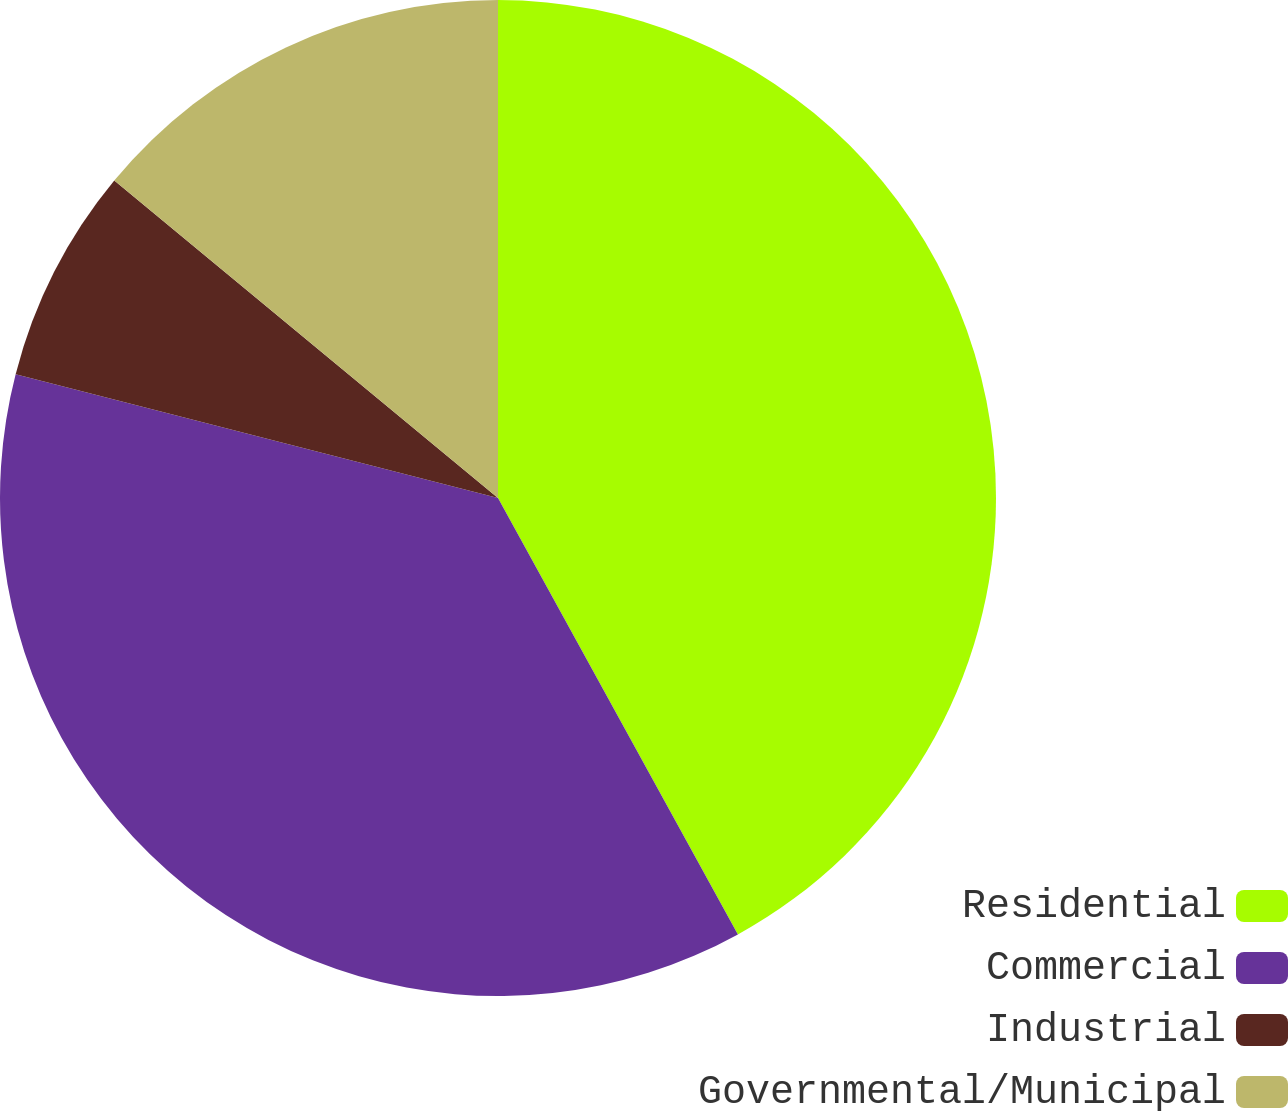Convert chart. <chart><loc_0><loc_0><loc_500><loc_500><pie_chart><fcel>Residential<fcel>Commercial<fcel>Industrial<fcel>Governmental/Municipal<nl><fcel>42.0%<fcel>37.0%<fcel>7.0%<fcel>14.0%<nl></chart> 